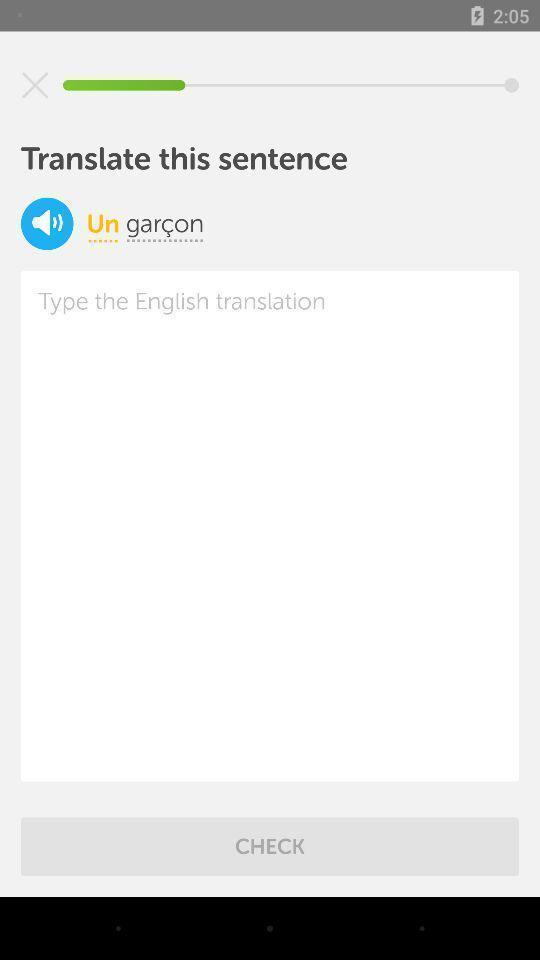What is the overall content of this screenshot? Translation page. 